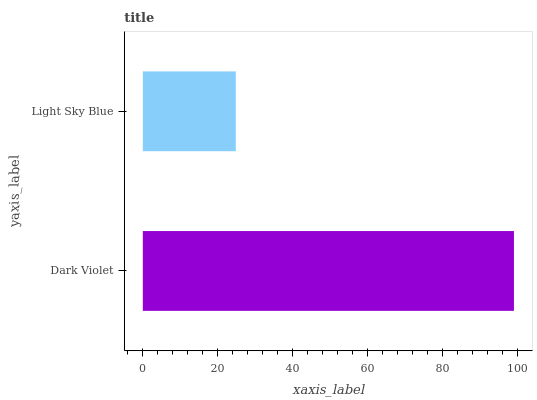Is Light Sky Blue the minimum?
Answer yes or no. Yes. Is Dark Violet the maximum?
Answer yes or no. Yes. Is Light Sky Blue the maximum?
Answer yes or no. No. Is Dark Violet greater than Light Sky Blue?
Answer yes or no. Yes. Is Light Sky Blue less than Dark Violet?
Answer yes or no. Yes. Is Light Sky Blue greater than Dark Violet?
Answer yes or no. No. Is Dark Violet less than Light Sky Blue?
Answer yes or no. No. Is Dark Violet the high median?
Answer yes or no. Yes. Is Light Sky Blue the low median?
Answer yes or no. Yes. Is Light Sky Blue the high median?
Answer yes or no. No. Is Dark Violet the low median?
Answer yes or no. No. 